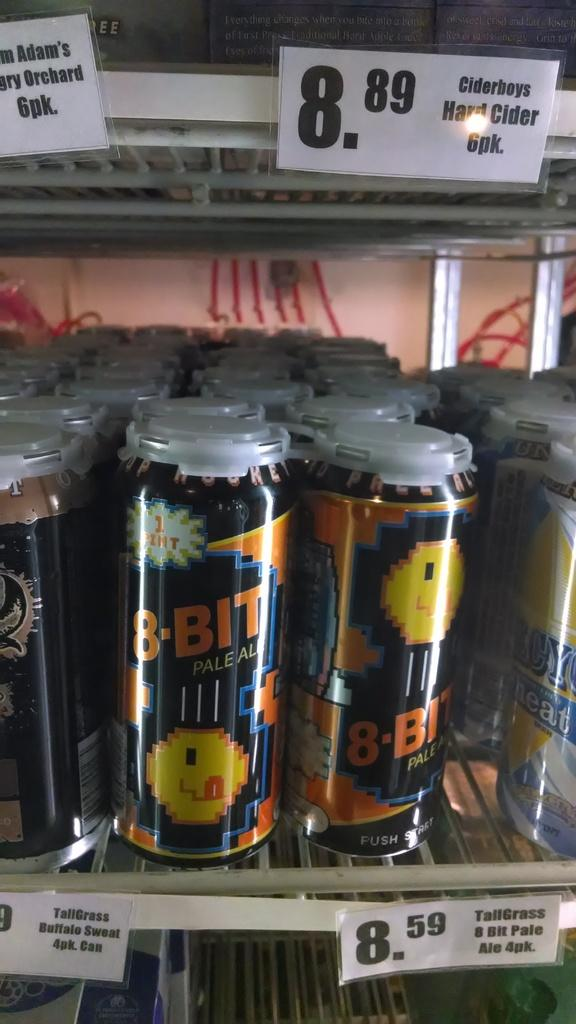What objects are present in the image? There are many tins in the image. How are the tins arranged in the image? The tins are in a rack. Are there any additional details about the tins? Price tags are attached to the tins. Where are these elements located in the image? These elements are located in the foreground of the image. What type of popcorn is being served at the committee meeting in the image? There is no committee meeting or popcorn present in the image; it features a rack of tins with price tags. 